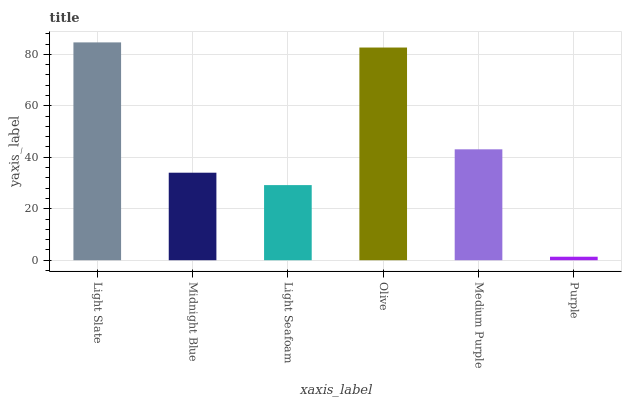Is Purple the minimum?
Answer yes or no. Yes. Is Light Slate the maximum?
Answer yes or no. Yes. Is Midnight Blue the minimum?
Answer yes or no. No. Is Midnight Blue the maximum?
Answer yes or no. No. Is Light Slate greater than Midnight Blue?
Answer yes or no. Yes. Is Midnight Blue less than Light Slate?
Answer yes or no. Yes. Is Midnight Blue greater than Light Slate?
Answer yes or no. No. Is Light Slate less than Midnight Blue?
Answer yes or no. No. Is Medium Purple the high median?
Answer yes or no. Yes. Is Midnight Blue the low median?
Answer yes or no. Yes. Is Purple the high median?
Answer yes or no. No. Is Medium Purple the low median?
Answer yes or no. No. 